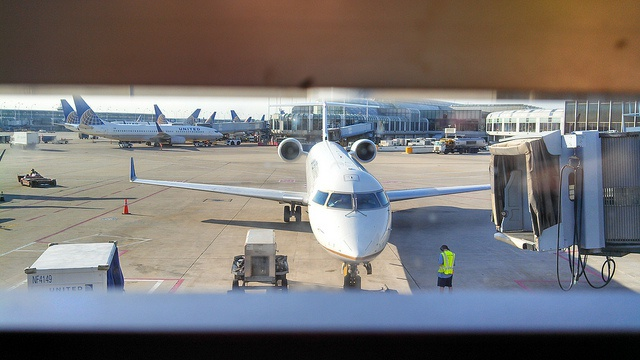Describe the objects in this image and their specific colors. I can see airplane in black, white, darkgray, and gray tones, truck in black, lightgray, darkgray, gray, and navy tones, airplane in black, gray, and darkgray tones, truck in black, gray, darkgray, and lightgray tones, and airplane in black, gray, and darkgray tones in this image. 